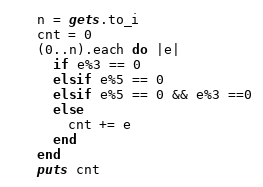<code> <loc_0><loc_0><loc_500><loc_500><_Ruby_>n = gets.to_i
cnt = 0
(0..n).each do |e|
  if e%3 == 0
  elsif e%5 == 0
  elsif e%5 == 0 && e%3 ==0
  else
    cnt += e
  end
end
puts cnt
</code> 